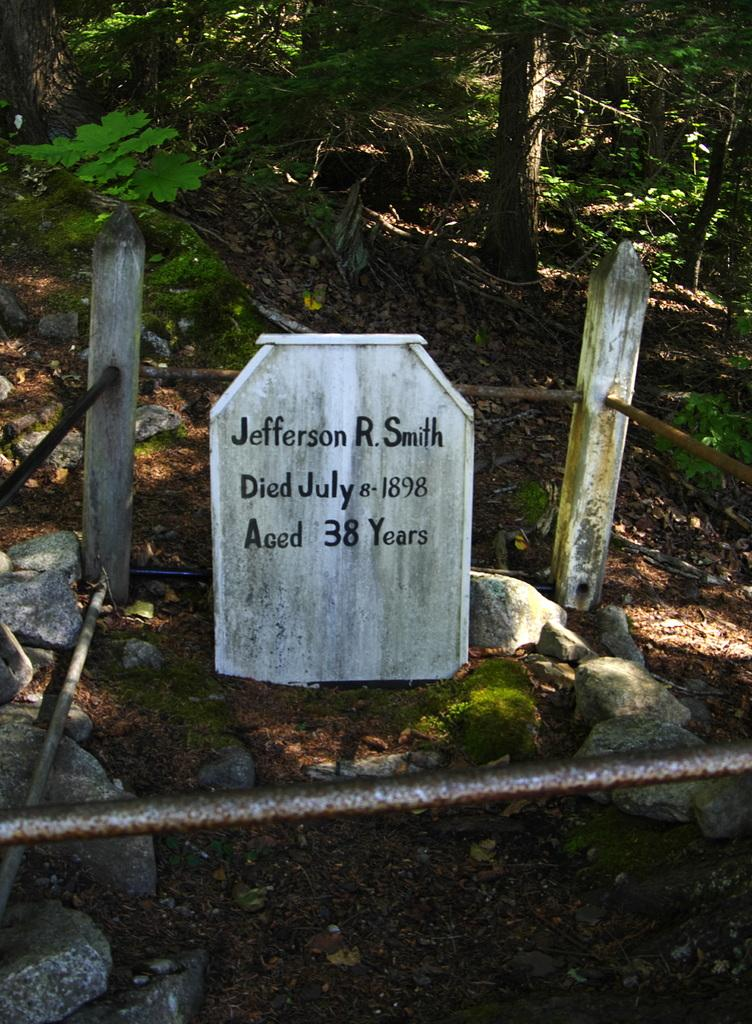What is the main object in the image? There is a gravestone in the image. What can be found on the gravestone? There is writing on the gravestone. What other objects are present in the image? There are poles and metal rods in the image. What can be seen in the background of the image? There are trees in the background of the image. What type of underwear is hanging on the poles in the image? There is no underwear present in the image; it only features a gravestone, writing, poles, metal rods, and trees in the background. 